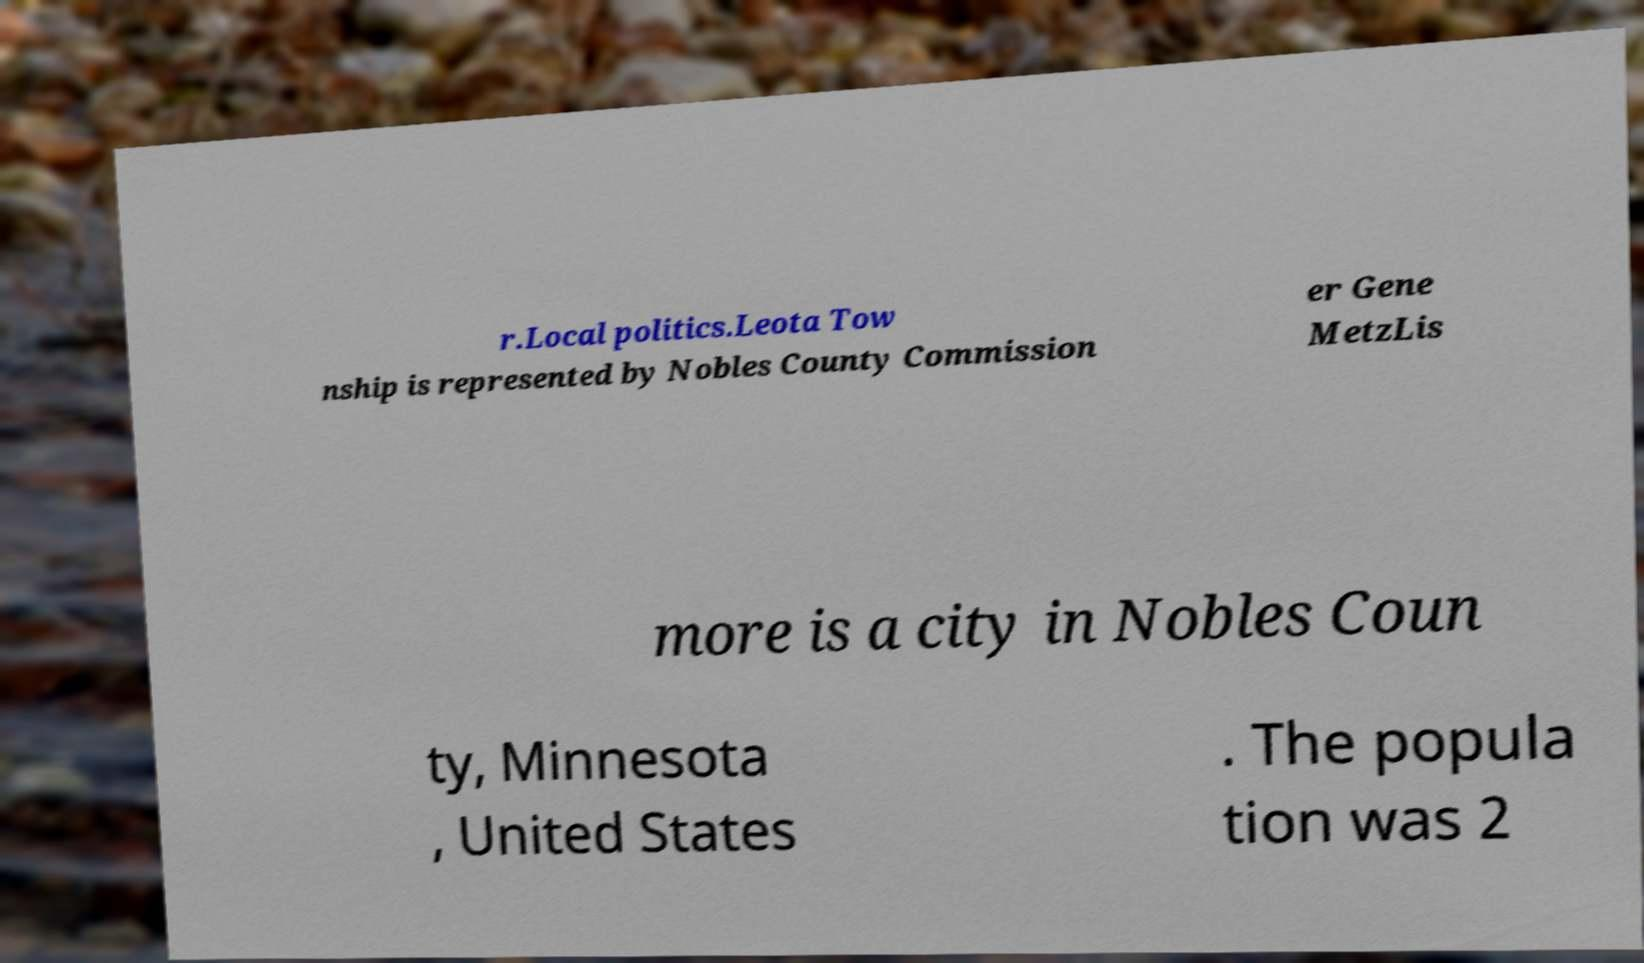Can you accurately transcribe the text from the provided image for me? r.Local politics.Leota Tow nship is represented by Nobles County Commission er Gene MetzLis more is a city in Nobles Coun ty, Minnesota , United States . The popula tion was 2 